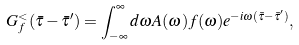Convert formula to latex. <formula><loc_0><loc_0><loc_500><loc_500>G _ { f } ^ { < } ( \bar { \tau } - \bar { \tau } ^ { \prime } ) = \int _ { - \infty } ^ { \infty } d \omega A ( \omega ) f ( \omega ) e ^ { - i \omega ( \bar { \tau } - \bar { \tau } ^ { \prime } ) } ,</formula> 